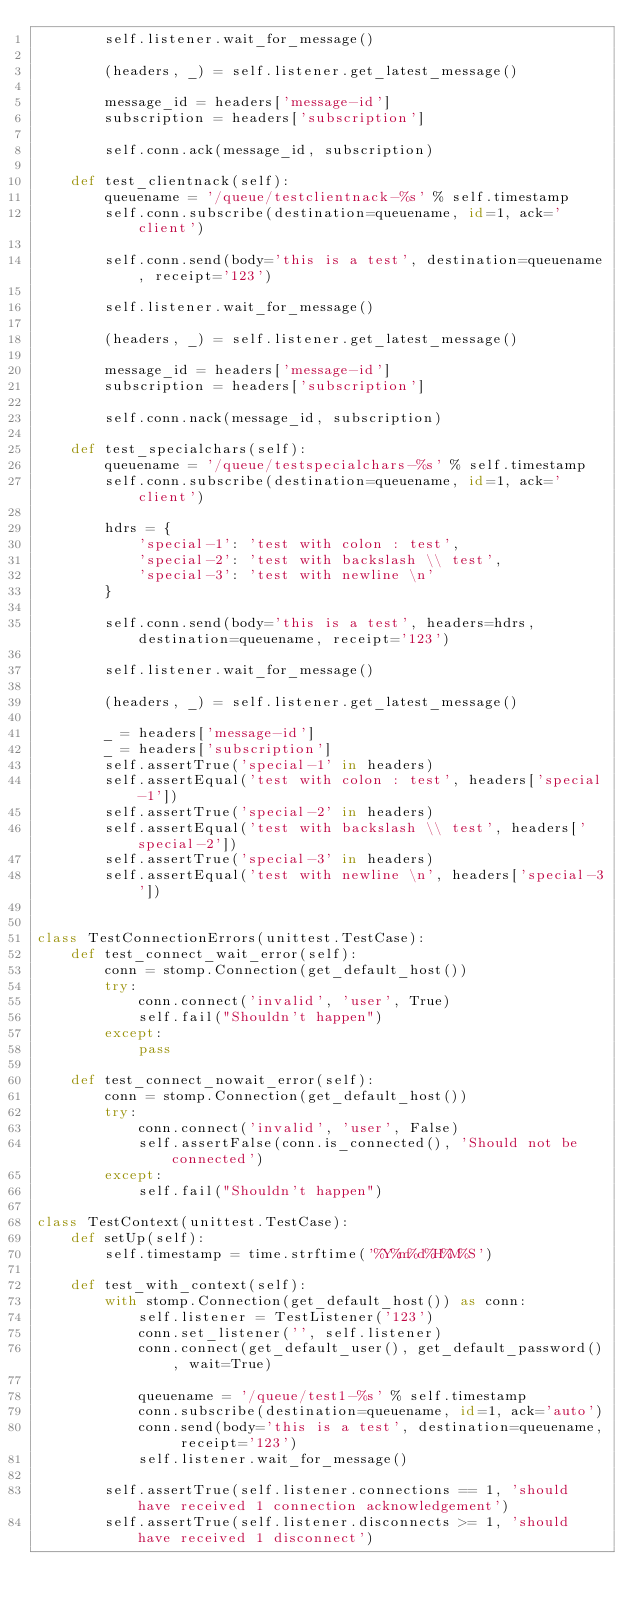Convert code to text. <code><loc_0><loc_0><loc_500><loc_500><_Python_>        self.listener.wait_for_message()

        (headers, _) = self.listener.get_latest_message()

        message_id = headers['message-id']
        subscription = headers['subscription']

        self.conn.ack(message_id, subscription)

    def test_clientnack(self):
        queuename = '/queue/testclientnack-%s' % self.timestamp
        self.conn.subscribe(destination=queuename, id=1, ack='client')

        self.conn.send(body='this is a test', destination=queuename, receipt='123')

        self.listener.wait_for_message()

        (headers, _) = self.listener.get_latest_message()

        message_id = headers['message-id']
        subscription = headers['subscription']

        self.conn.nack(message_id, subscription)

    def test_specialchars(self):
        queuename = '/queue/testspecialchars-%s' % self.timestamp
        self.conn.subscribe(destination=queuename, id=1, ack='client')

        hdrs = {
            'special-1': 'test with colon : test',
            'special-2': 'test with backslash \\ test',
            'special-3': 'test with newline \n'
        }

        self.conn.send(body='this is a test', headers=hdrs, destination=queuename, receipt='123')

        self.listener.wait_for_message()

        (headers, _) = self.listener.get_latest_message()

        _ = headers['message-id']
        _ = headers['subscription']
        self.assertTrue('special-1' in headers)
        self.assertEqual('test with colon : test', headers['special-1'])
        self.assertTrue('special-2' in headers)
        self.assertEqual('test with backslash \\ test', headers['special-2'])
        self.assertTrue('special-3' in headers)
        self.assertEqual('test with newline \n', headers['special-3'])


class TestConnectionErrors(unittest.TestCase):
    def test_connect_wait_error(self):
        conn = stomp.Connection(get_default_host())
        try:
            conn.connect('invalid', 'user', True)
            self.fail("Shouldn't happen")
        except:
            pass

    def test_connect_nowait_error(self):
        conn = stomp.Connection(get_default_host())
        try:
            conn.connect('invalid', 'user', False)
            self.assertFalse(conn.is_connected(), 'Should not be connected')
        except:
            self.fail("Shouldn't happen")

class TestContext(unittest.TestCase):
    def setUp(self):
        self.timestamp = time.strftime('%Y%m%d%H%M%S')

    def test_with_context(self):
        with stomp.Connection(get_default_host()) as conn:
            self.listener = TestListener('123')
            conn.set_listener('', self.listener)
            conn.connect(get_default_user(), get_default_password(), wait=True)

            queuename = '/queue/test1-%s' % self.timestamp
            conn.subscribe(destination=queuename, id=1, ack='auto')
            conn.send(body='this is a test', destination=queuename, receipt='123')
            self.listener.wait_for_message()

        self.assertTrue(self.listener.connections == 1, 'should have received 1 connection acknowledgement')
        self.assertTrue(self.listener.disconnects >= 1, 'should have received 1 disconnect')</code> 